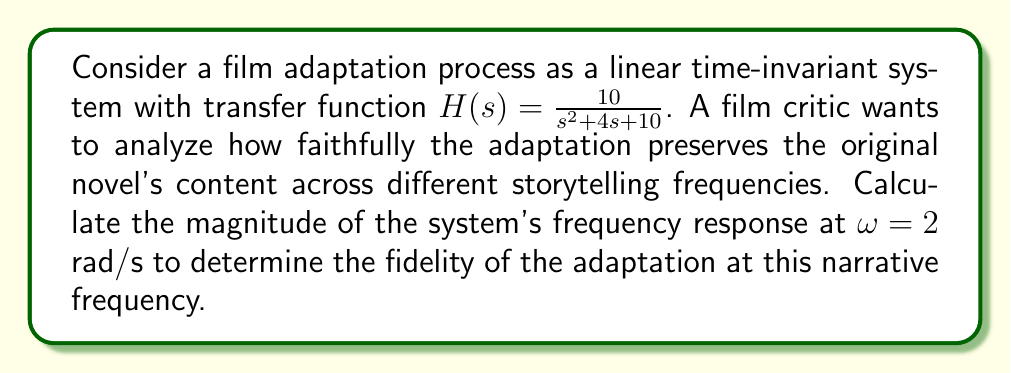Can you answer this question? To analyze the frequency response of the system and determine the film adaptation fidelity, we need to follow these steps:

1) The transfer function is given as:
   $$H(s) = \frac{10}{s^2 + 4s + 10}$$

2) To find the frequency response, we substitute $s$ with $j\omega$:
   $$H(j\omega) = \frac{10}{(j\omega)^2 + 4(j\omega) + 10}$$

3) For $\omega = 2$ rad/s, we have:
   $$H(j2) = \frac{10}{(j2)^2 + 4(j2) + 10}$$

4) Simplify the denominator:
   $$H(j2) = \frac{10}{-4 + 8j + 10} = \frac{10}{6 + 8j}$$

5) To find the magnitude, we use the formula:
   $$|H(j\omega)| = \sqrt{\frac{(\text{Real part})^2 + (\text{Imaginary part})^2}{(\text{Real part of denominator})^2 + (\text{Imaginary part of denominator})^2}}$$

6) Substituting the values:
   $$|H(j2)| = \sqrt{\frac{10^2}{6^2 + 8^2}} = \sqrt{\frac{100}{36 + 64}} = \sqrt{\frac{100}{100}} = 1$$

The magnitude of 1 at $\omega = 2$ rad/s indicates that the film adaptation perfectly preserves the content of the original novel at this narrative frequency.
Answer: The magnitude of the system's frequency response at $\omega = 2$ rad/s is 1. 